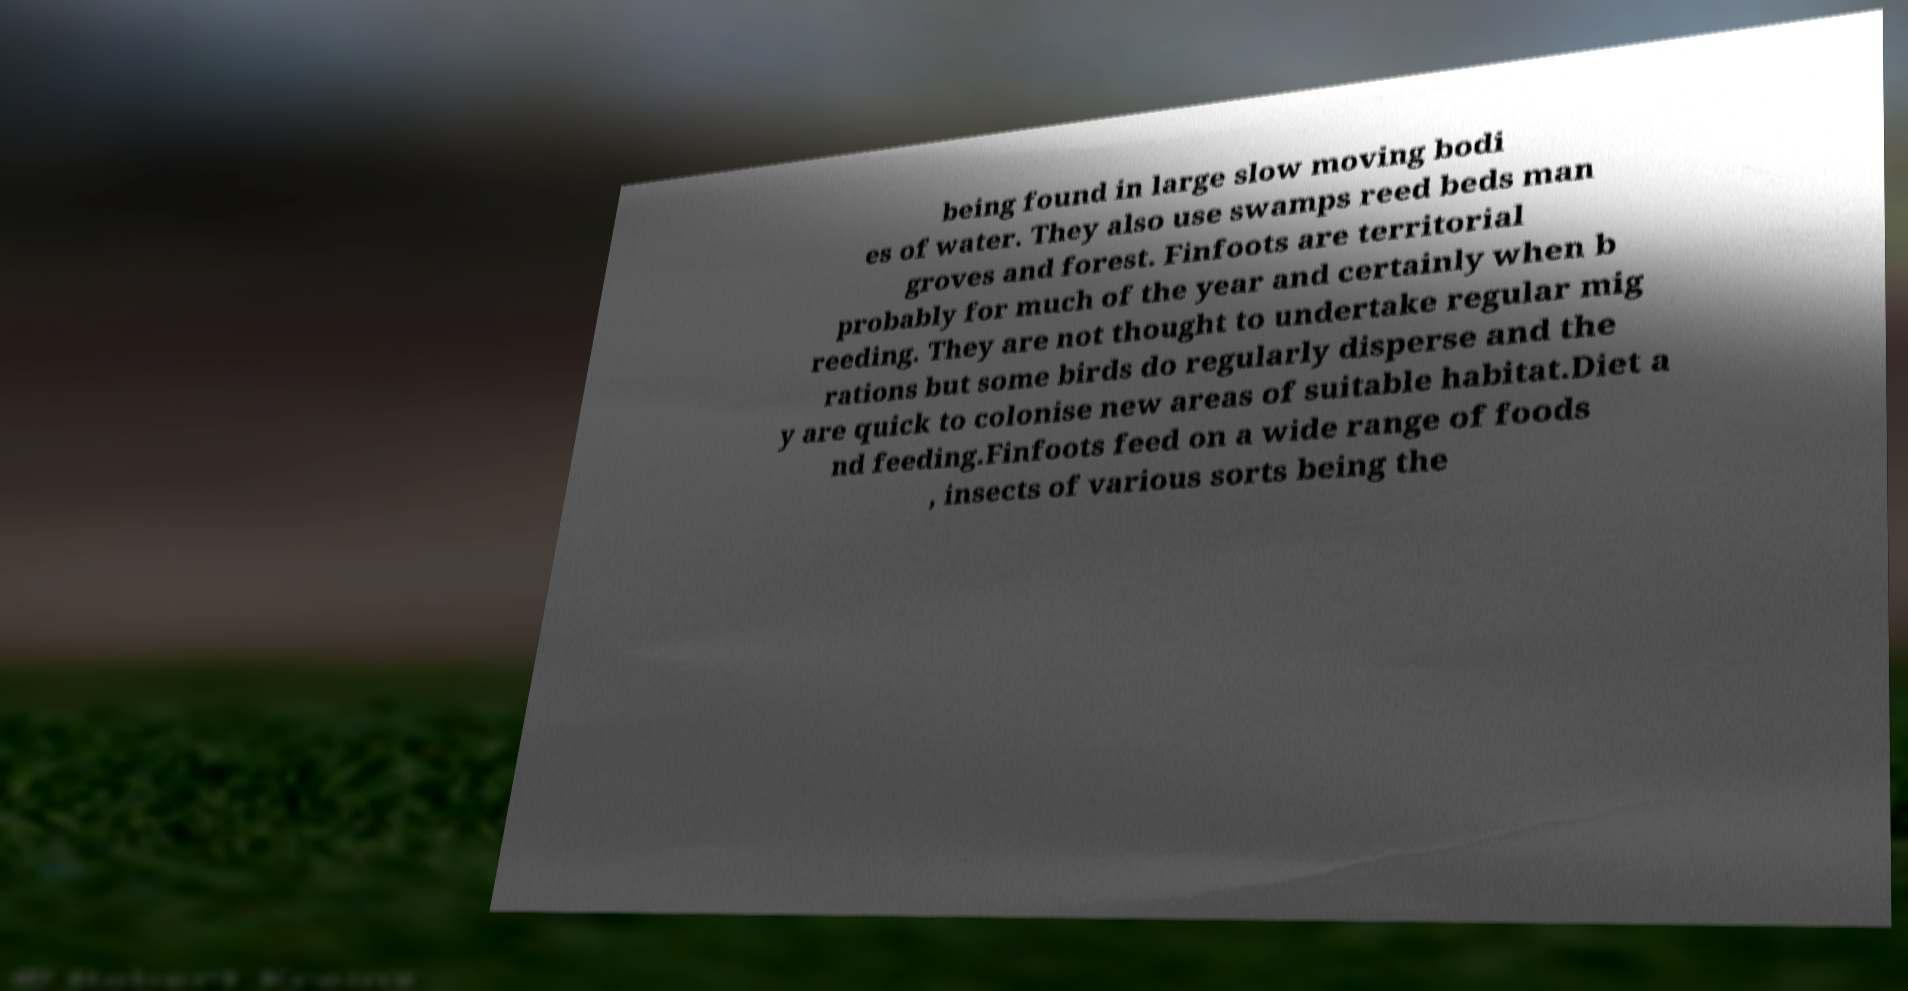I need the written content from this picture converted into text. Can you do that? being found in large slow moving bodi es of water. They also use swamps reed beds man groves and forest. Finfoots are territorial probably for much of the year and certainly when b reeding. They are not thought to undertake regular mig rations but some birds do regularly disperse and the y are quick to colonise new areas of suitable habitat.Diet a nd feeding.Finfoots feed on a wide range of foods , insects of various sorts being the 